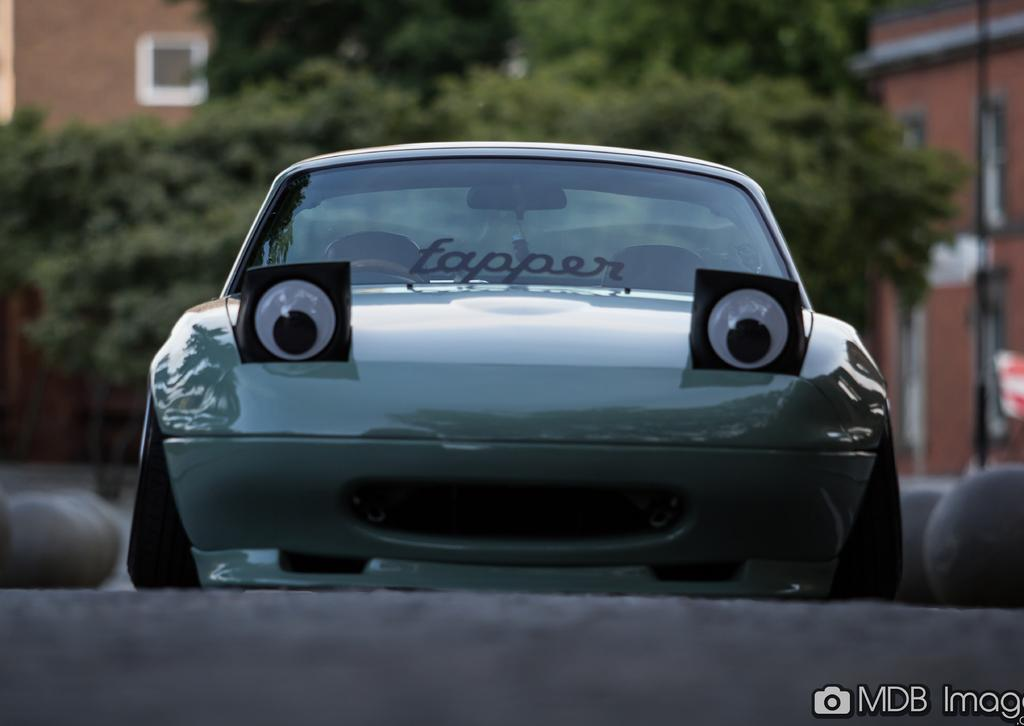What is the main subject of the image? The main subject of the image is a car on the road. What can be seen in the background of the image? There are trees and buildings in the background of the image. What type of advertisement can be seen on the car in the image? There is no advertisement visible on the car in the image. What is the car using to support its weight in the image? The car is not shown using any visible support in the image; it is resting on the road. 